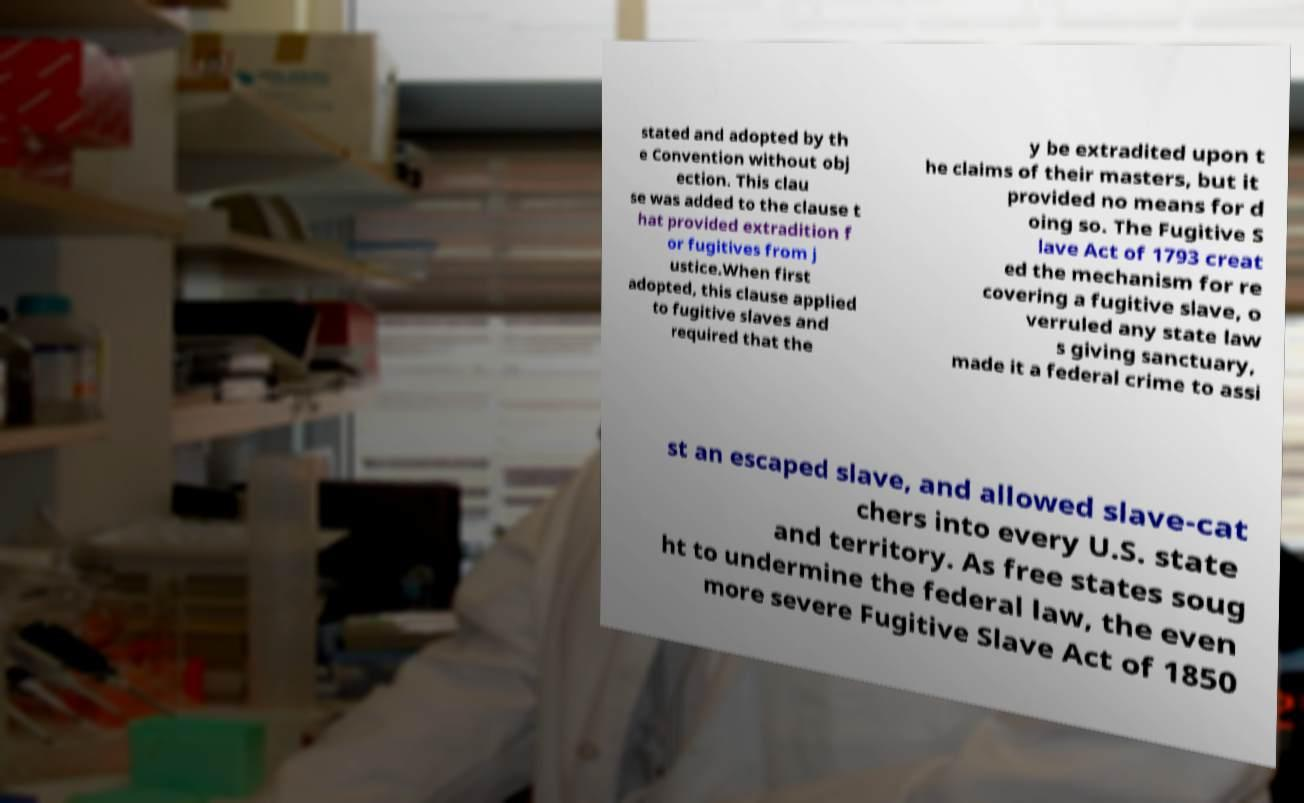Can you accurately transcribe the text from the provided image for me? stated and adopted by th e Convention without obj ection. This clau se was added to the clause t hat provided extradition f or fugitives from j ustice.When first adopted, this clause applied to fugitive slaves and required that the y be extradited upon t he claims of their masters, but it provided no means for d oing so. The Fugitive S lave Act of 1793 creat ed the mechanism for re covering a fugitive slave, o verruled any state law s giving sanctuary, made it a federal crime to assi st an escaped slave, and allowed slave-cat chers into every U.S. state and territory. As free states soug ht to undermine the federal law, the even more severe Fugitive Slave Act of 1850 